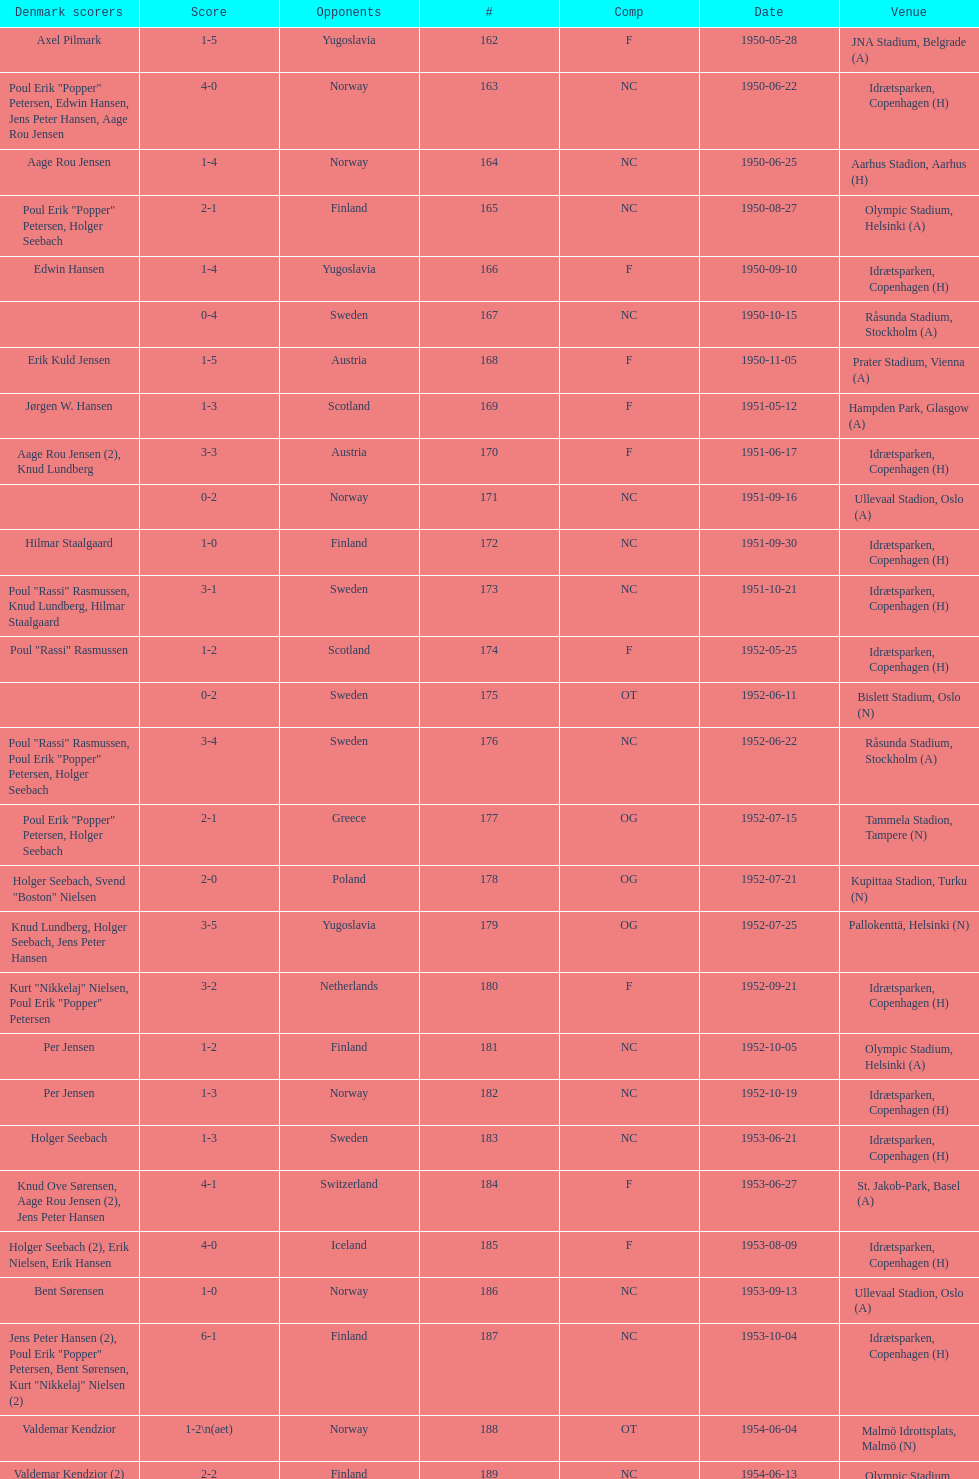Which venue was listed immediately preceding olympic stadium on the date of august 27, 1950? Aarhus Stadion, Aarhus. 